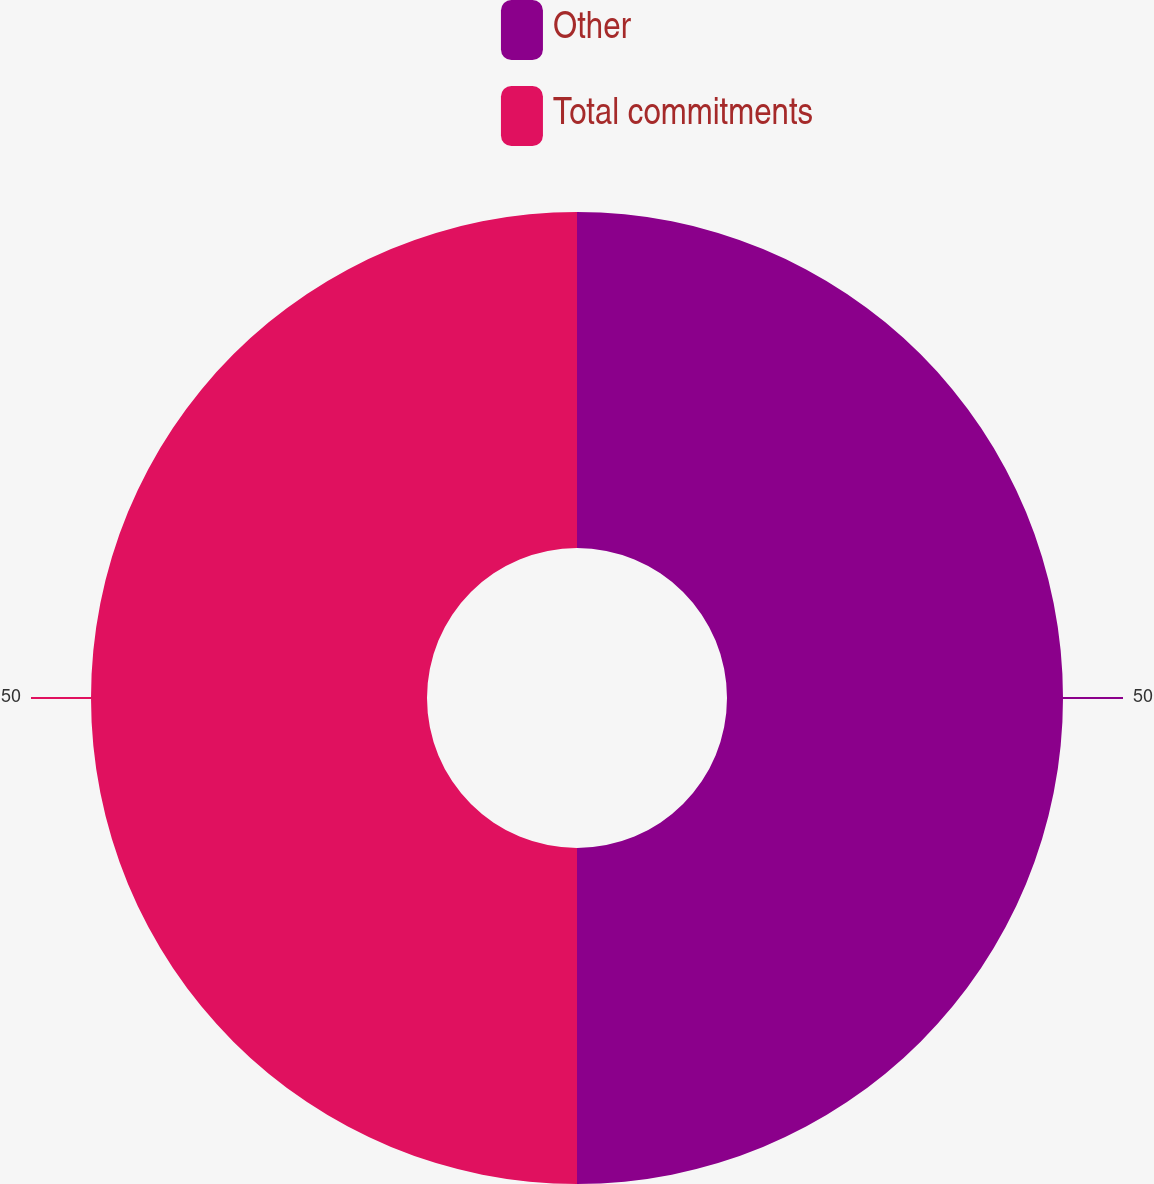Convert chart to OTSL. <chart><loc_0><loc_0><loc_500><loc_500><pie_chart><fcel>Other<fcel>Total commitments<nl><fcel>50.0%<fcel>50.0%<nl></chart> 